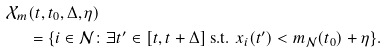<formula> <loc_0><loc_0><loc_500><loc_500>\mathcal { X } _ { m } & ( t , t _ { 0 } , \Delta , \eta ) \\ & = \{ i \in \mathcal { N } \colon \exists t ^ { \prime } \in [ t , t + \Delta ] \text { s.t. } x _ { i } ( t ^ { \prime } ) < m _ { \mathcal { N } } ( t _ { 0 } ) + \eta \} .</formula> 